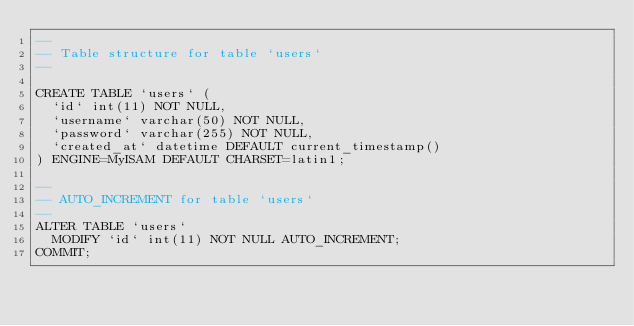<code> <loc_0><loc_0><loc_500><loc_500><_SQL_>--
-- Table structure for table `users`
--

CREATE TABLE `users` (
  `id` int(11) NOT NULL,
  `username` varchar(50) NOT NULL,
  `password` varchar(255) NOT NULL,
  `created_at` datetime DEFAULT current_timestamp()
) ENGINE=MyISAM DEFAULT CHARSET=latin1;

--
-- AUTO_INCREMENT for table `users`
--
ALTER TABLE `users`
  MODIFY `id` int(11) NOT NULL AUTO_INCREMENT;
COMMIT;</code> 